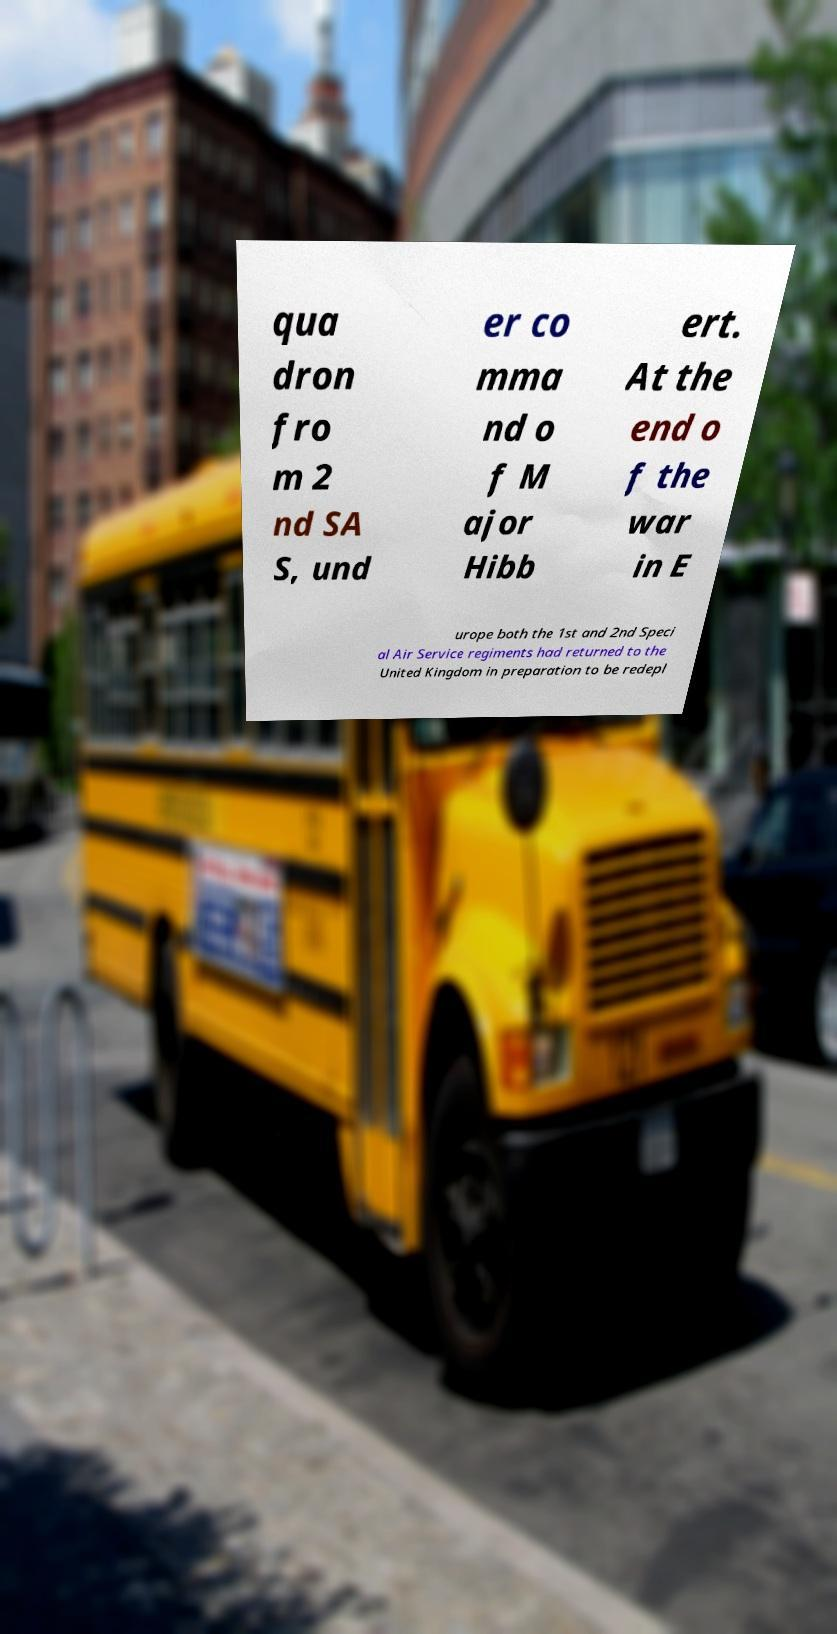What messages or text are displayed in this image? I need them in a readable, typed format. qua dron fro m 2 nd SA S, und er co mma nd o f M ajor Hibb ert. At the end o f the war in E urope both the 1st and 2nd Speci al Air Service regiments had returned to the United Kingdom in preparation to be redepl 